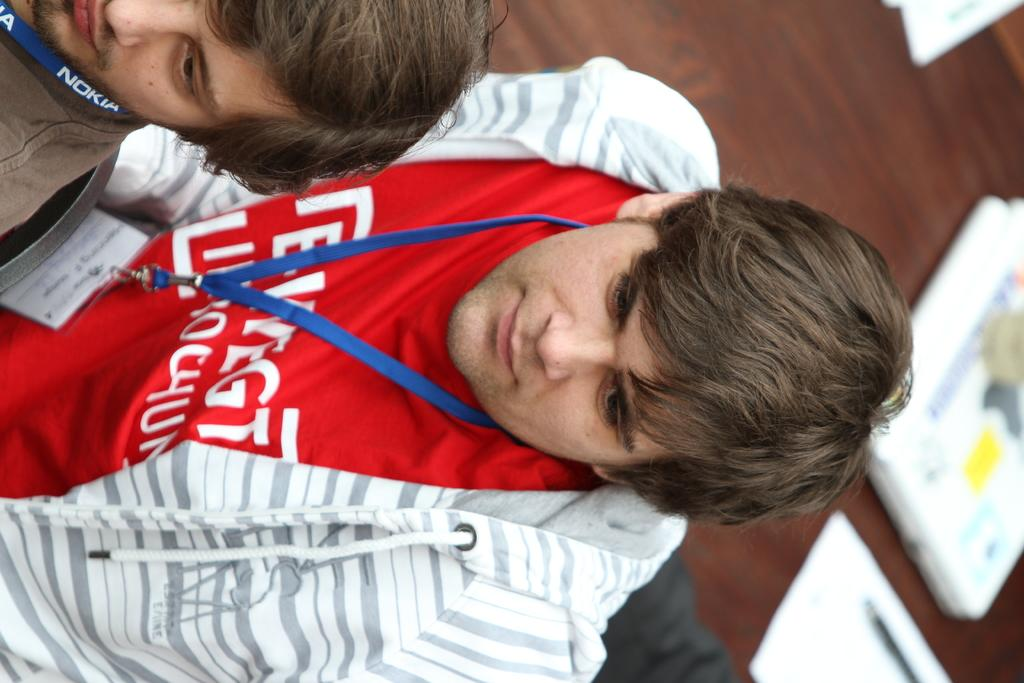<image>
Relay a brief, clear account of the picture shown. two men with lanyards around their necks with one reading NOKIA 